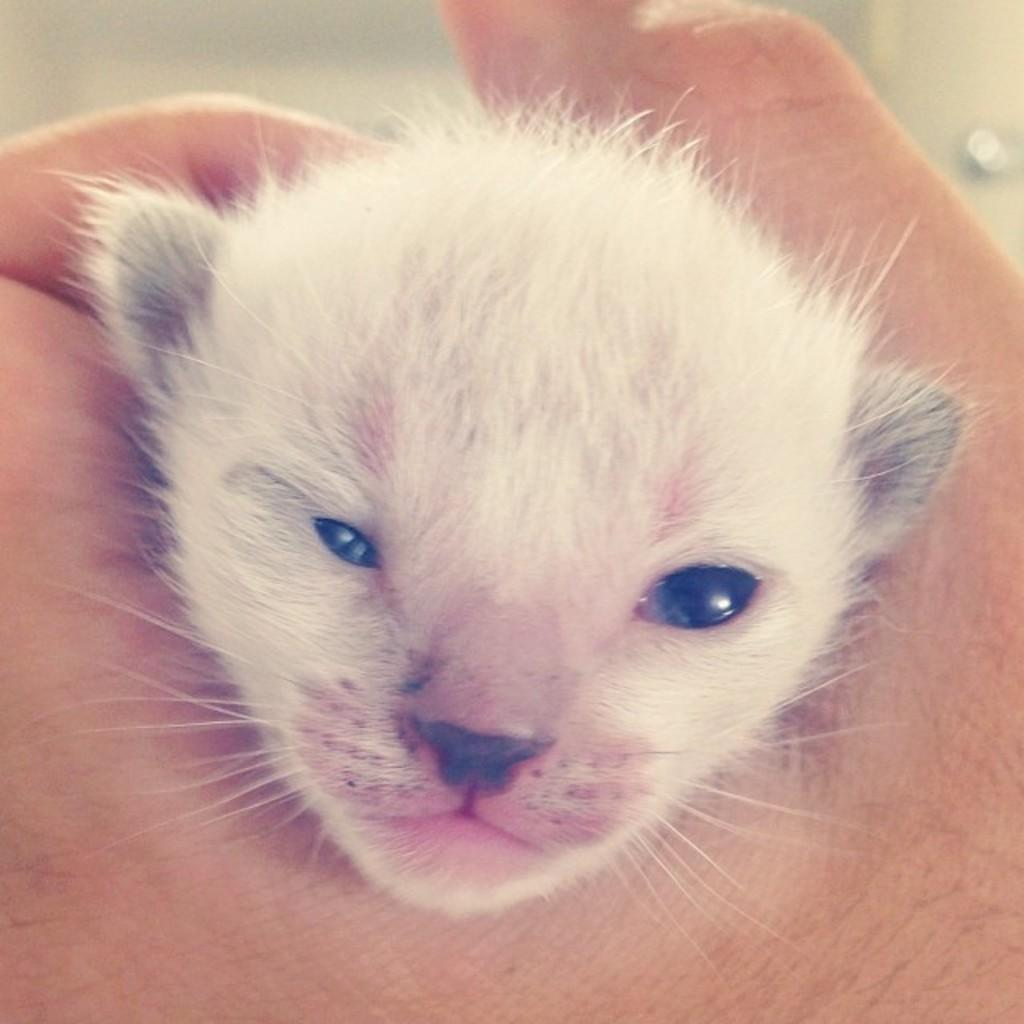What type of animal is present in the image? There is an animal in the image, and it is white in color. Can you describe the fur of the animal? The animal has white fur. How is the animal being held in the image? The animal is being held by a human. What is the condition of the snail in the image? There is no snail present in the image; the animal mentioned is white and has white fur. 